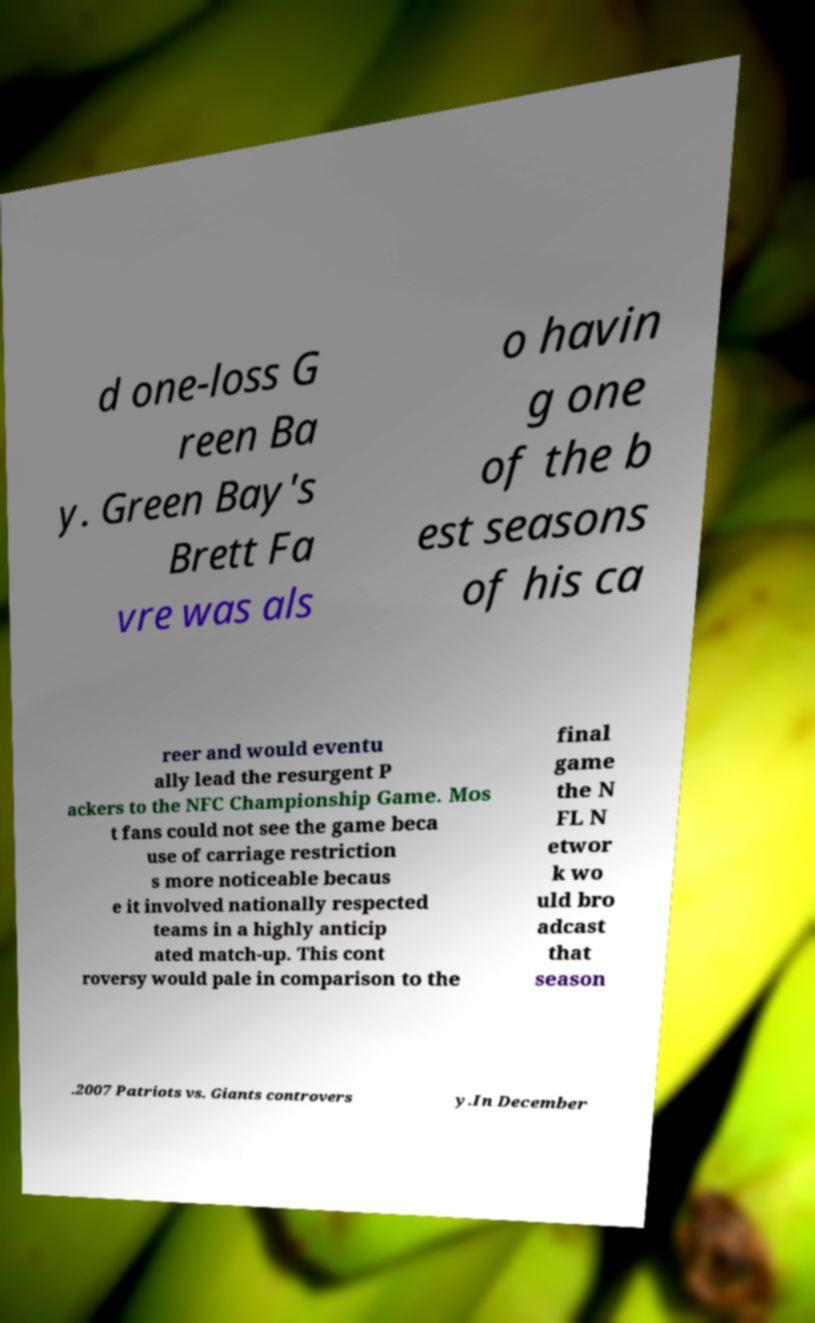What messages or text are displayed in this image? I need them in a readable, typed format. d one-loss G reen Ba y. Green Bay's Brett Fa vre was als o havin g one of the b est seasons of his ca reer and would eventu ally lead the resurgent P ackers to the NFC Championship Game. Mos t fans could not see the game beca use of carriage restriction s more noticeable becaus e it involved nationally respected teams in a highly anticip ated match-up. This cont roversy would pale in comparison to the final game the N FL N etwor k wo uld bro adcast that season .2007 Patriots vs. Giants controvers y.In December 